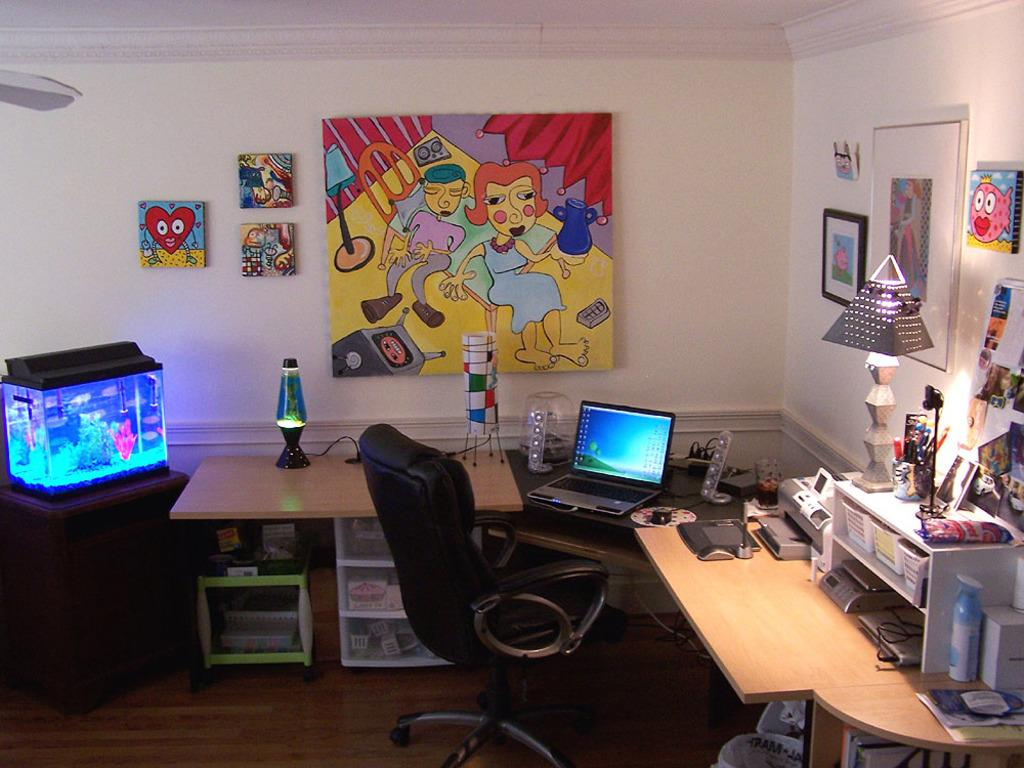What type of space is depicted in the image? There is a room in the image. What furniture is present in the room? There are tables and chairs in the room. What electronic device can be seen in the room? There is a laptop in the room. What type of decoration is present in the room? There is an aquarium in the room, and the walls have paintings. What color are the leaves on the tree in the image? There is no tree present in the image. What type of teeth can be seen in the image? There are no teeth visible in the image. 